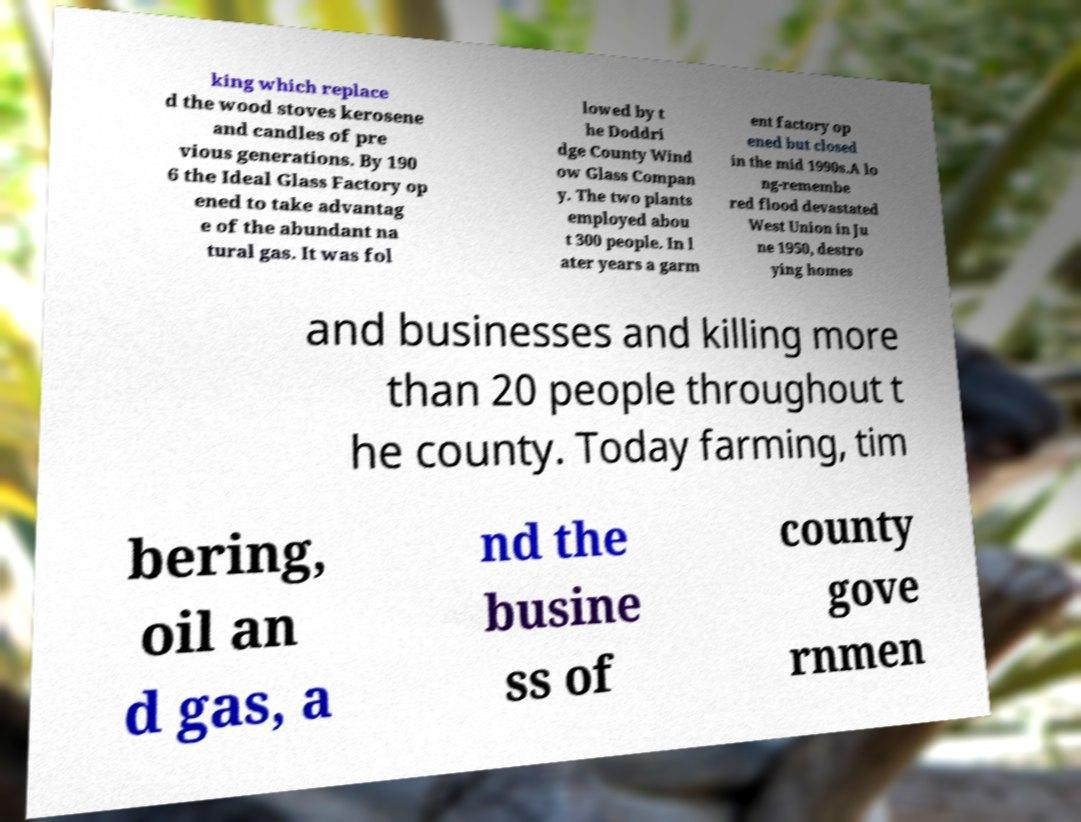What messages or text are displayed in this image? I need them in a readable, typed format. king which replace d the wood stoves kerosene and candles of pre vious generations. By 190 6 the Ideal Glass Factory op ened to take advantag e of the abundant na tural gas. It was fol lowed by t he Doddri dge County Wind ow Glass Compan y. The two plants employed abou t 300 people. In l ater years a garm ent factory op ened but closed in the mid 1990s.A lo ng-remembe red flood devastated West Union in Ju ne 1950, destro ying homes and businesses and killing more than 20 people throughout t he county. Today farming, tim bering, oil an d gas, a nd the busine ss of county gove rnmen 